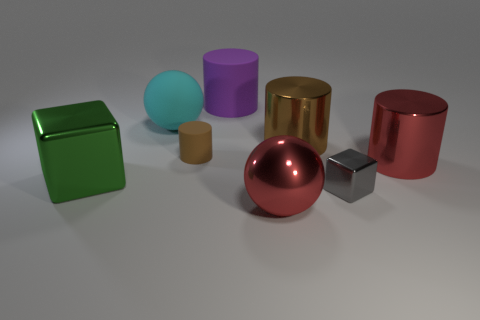Are the brown cylinder right of the brown rubber cylinder and the large red ball made of the same material?
Offer a terse response. Yes. What material is the small brown thing that is the same shape as the large purple thing?
Offer a very short reply. Rubber. Are there fewer red metal spheres than metal cylinders?
Ensure brevity in your answer.  Yes. There is a metallic cylinder that is on the right side of the small gray object; is it the same color as the large metallic ball?
Offer a terse response. Yes. There is a large ball that is the same material as the tiny cube; what color is it?
Your answer should be very brief. Red. Does the brown metal thing have the same size as the brown matte object?
Your answer should be compact. No. What is the gray block made of?
Ensure brevity in your answer.  Metal. There is a cyan sphere that is the same size as the red metallic cylinder; what is its material?
Keep it short and to the point. Rubber. Is there a brown rubber ball of the same size as the brown metallic cylinder?
Offer a very short reply. No. Are there an equal number of large rubber cylinders right of the big purple thing and tiny objects to the left of the large brown object?
Offer a very short reply. No. 